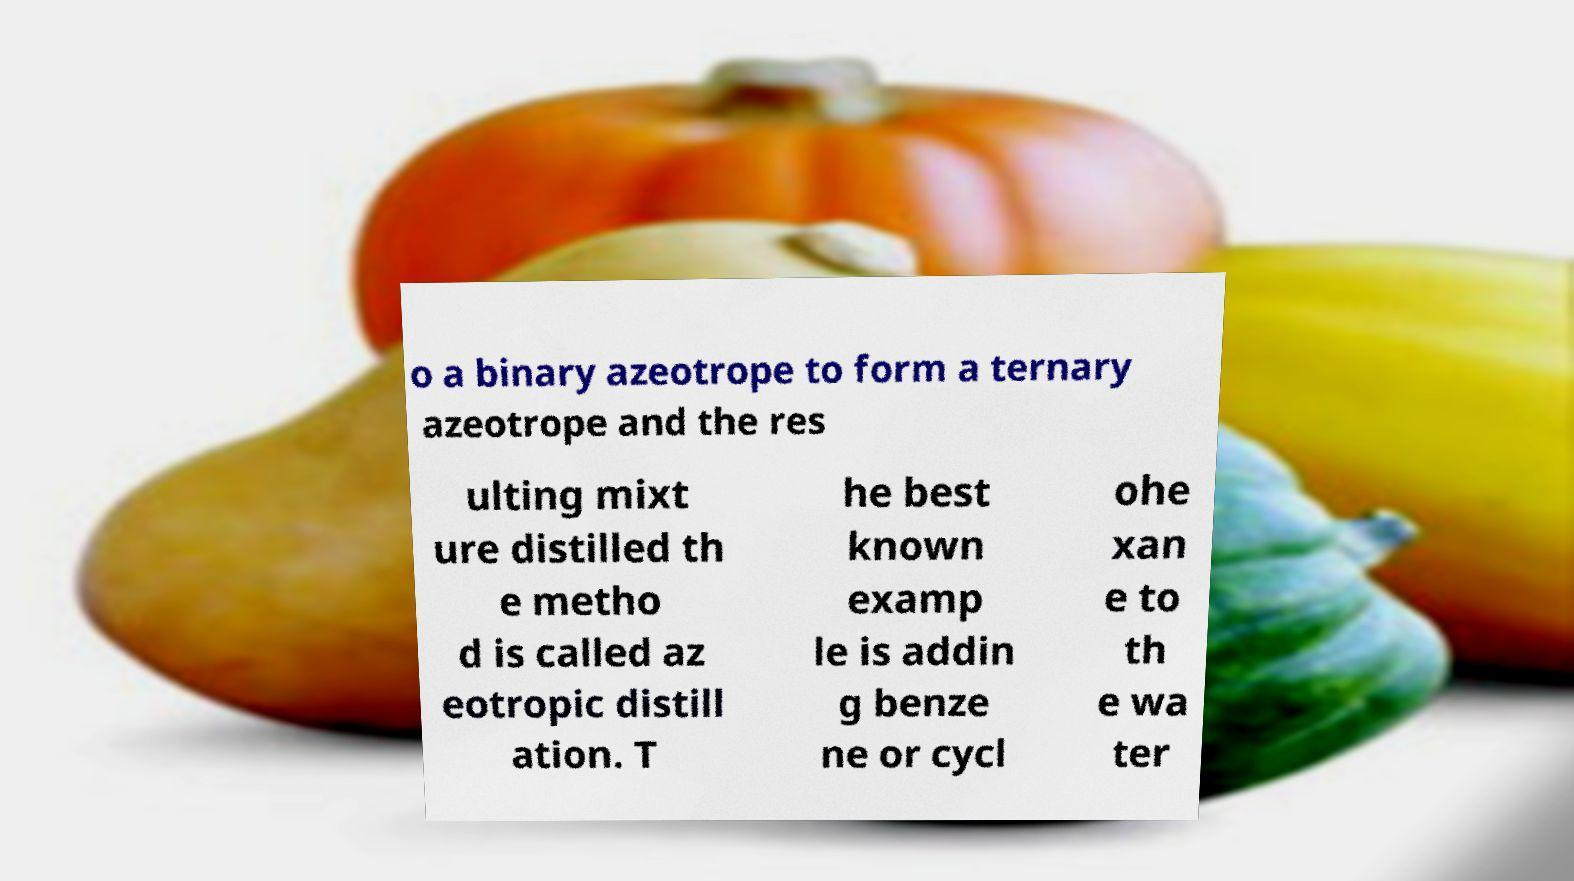Could you extract and type out the text from this image? o a binary azeotrope to form a ternary azeotrope and the res ulting mixt ure distilled th e metho d is called az eotropic distill ation. T he best known examp le is addin g benze ne or cycl ohe xan e to th e wa ter 